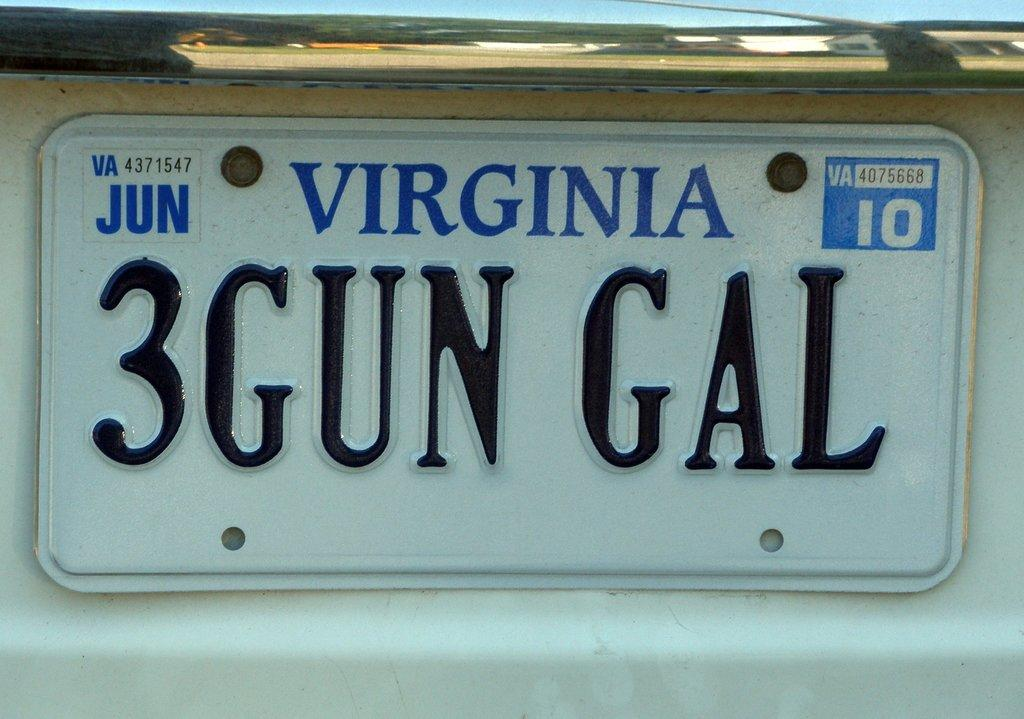Provide a one-sentence caption for the provided image. a close up of a Virginia license plate 3Gun Gal. 